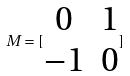<formula> <loc_0><loc_0><loc_500><loc_500>M = [ \begin{matrix} 0 & 1 \\ - 1 & 0 \end{matrix} ]</formula> 